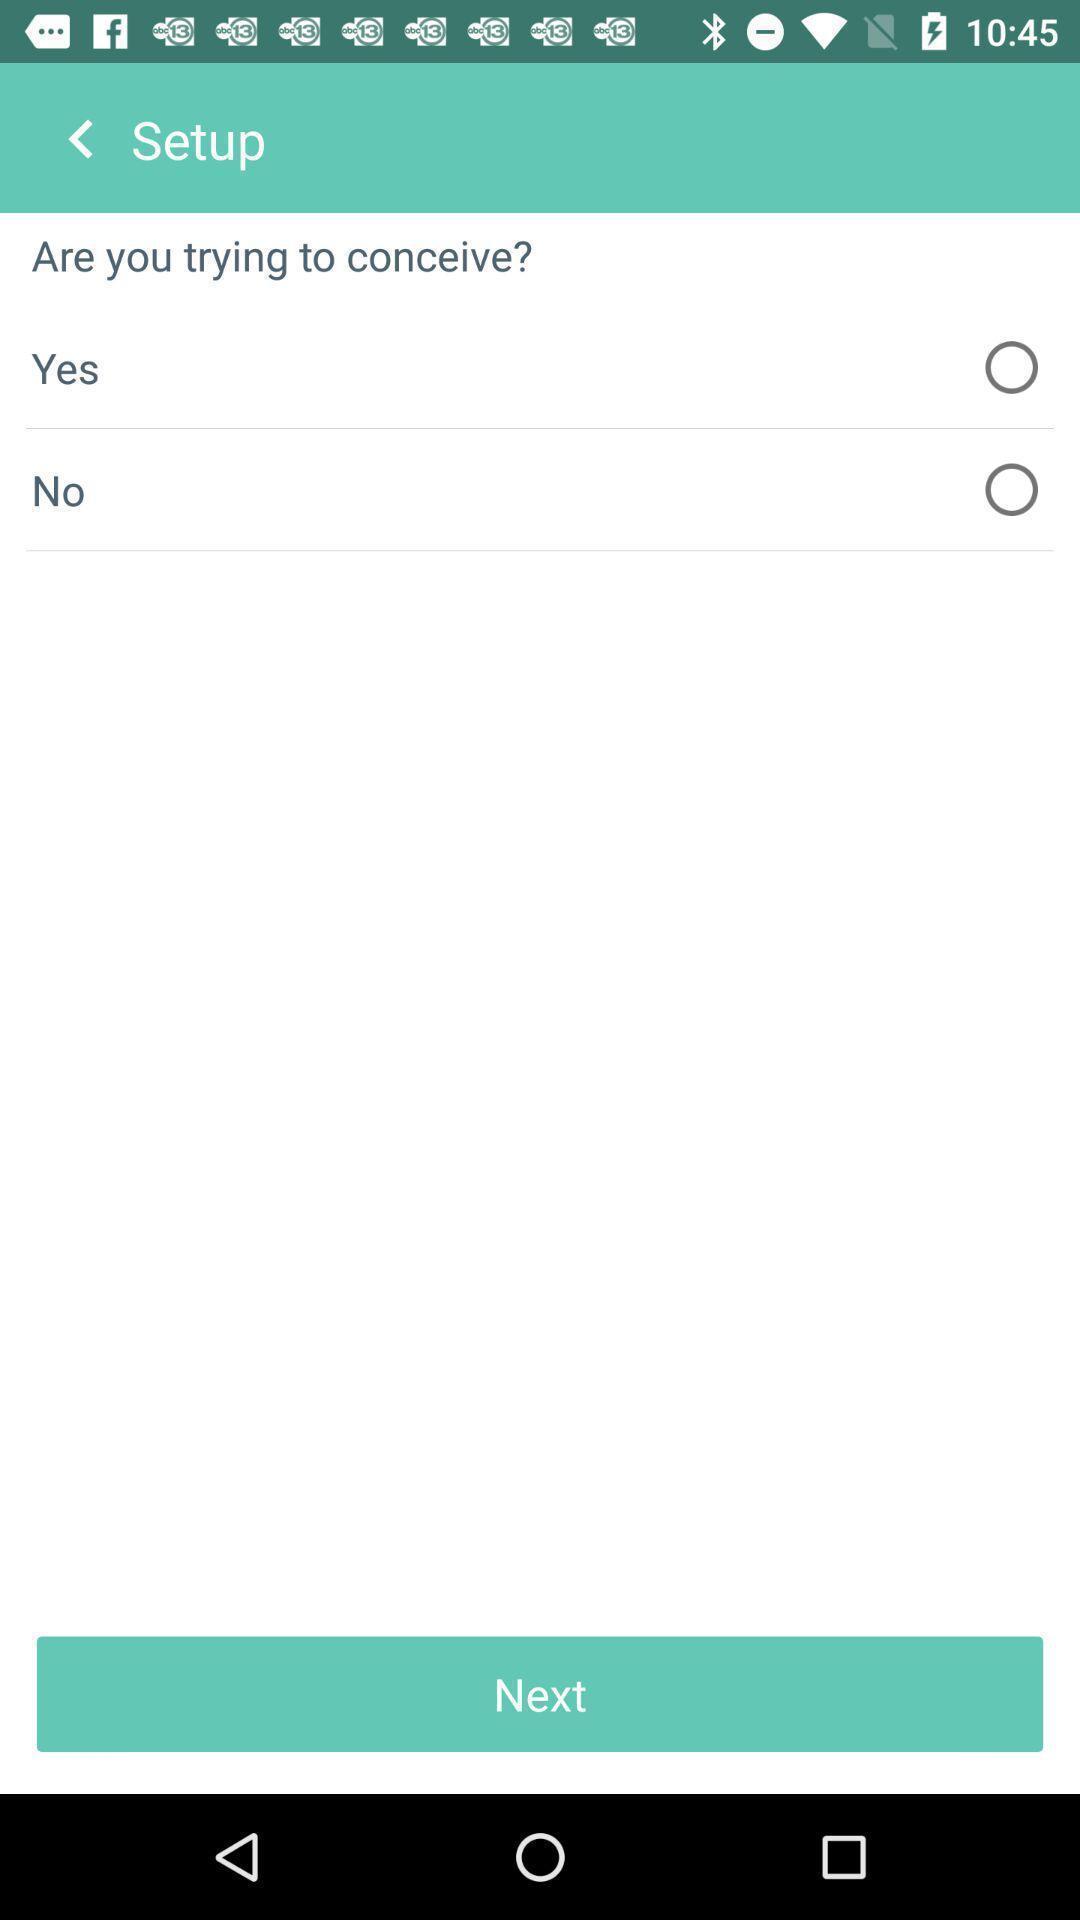What details can you identify in this image? Setup page displayed. 